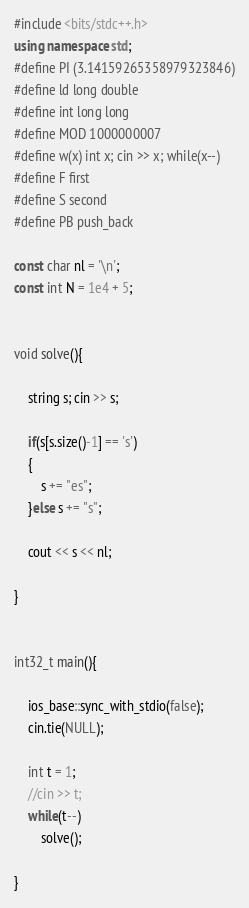<code> <loc_0><loc_0><loc_500><loc_500><_C++_>#include <bits/stdc++.h>
using namespace std;
#define PI (3.14159265358979323846)
#define ld long double
#define int long long
#define MOD 1000000007
#define w(x) int x; cin >> x; while(x--)
#define F first
#define S second
#define PB push_back
     
const char nl = '\n';
const int N = 1e4 + 5;


void solve(){
 
    string s; cin >> s;

    if(s[s.size()-1] == 's')
    {
        s += "es";
    }else s += "s";    

    cout << s << nl;

}   


int32_t main(){
         
    ios_base::sync_with_stdio(false);
    cin.tie(NULL);
        
    int t = 1;
    //cin >> t;
    while(t--) 
        solve();

}</code> 